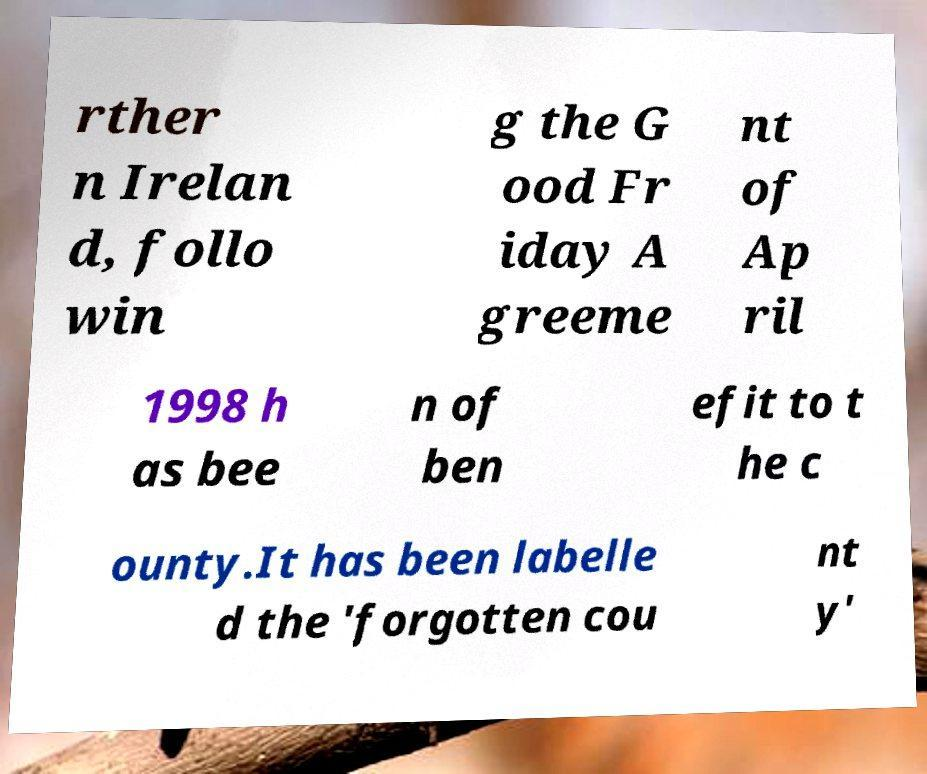Please read and relay the text visible in this image. What does it say? rther n Irelan d, follo win g the G ood Fr iday A greeme nt of Ap ril 1998 h as bee n of ben efit to t he c ounty.It has been labelle d the 'forgotten cou nt y' 